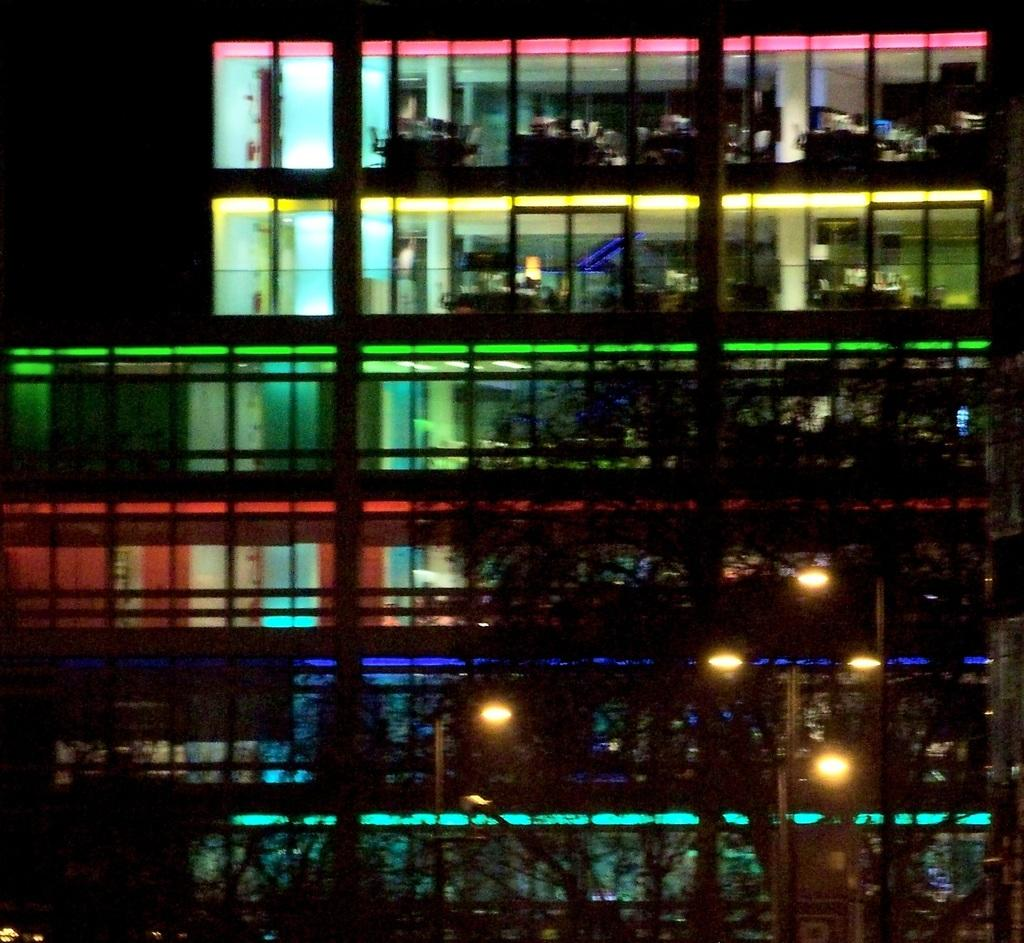What can be seen illuminated in the image? There are lights visible in the image. What type of natural elements are present in the image? There are trees in the image. What type of structure can be seen in the background of the image? There is a building in the background of the image. What part of the image appears to be dark? The top left corner of the image appears to be dark. What type of request is being made by the son in the image? There is no son present in the image, and therefore no request can be observed. What type of cart is visible in the image? There is no cart present in the image. 